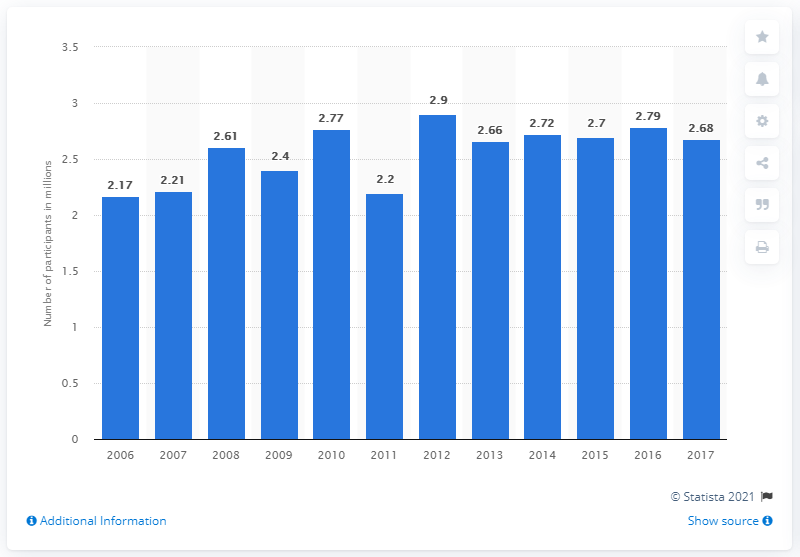Highlight a few significant elements in this photo. In 2017, approximately 2.68 million people participated in surfing in the United States. 